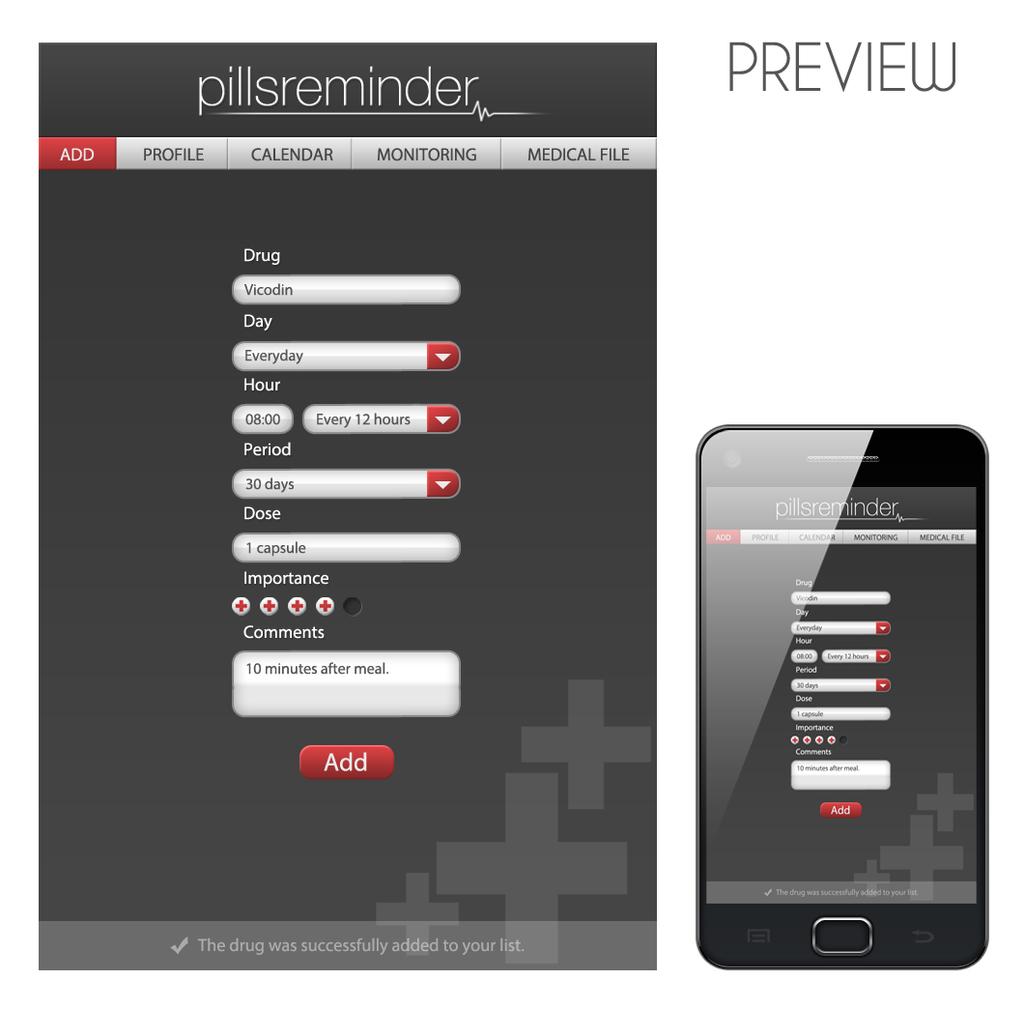What is the name of this app?
Offer a very short reply. Pillsreminder. 